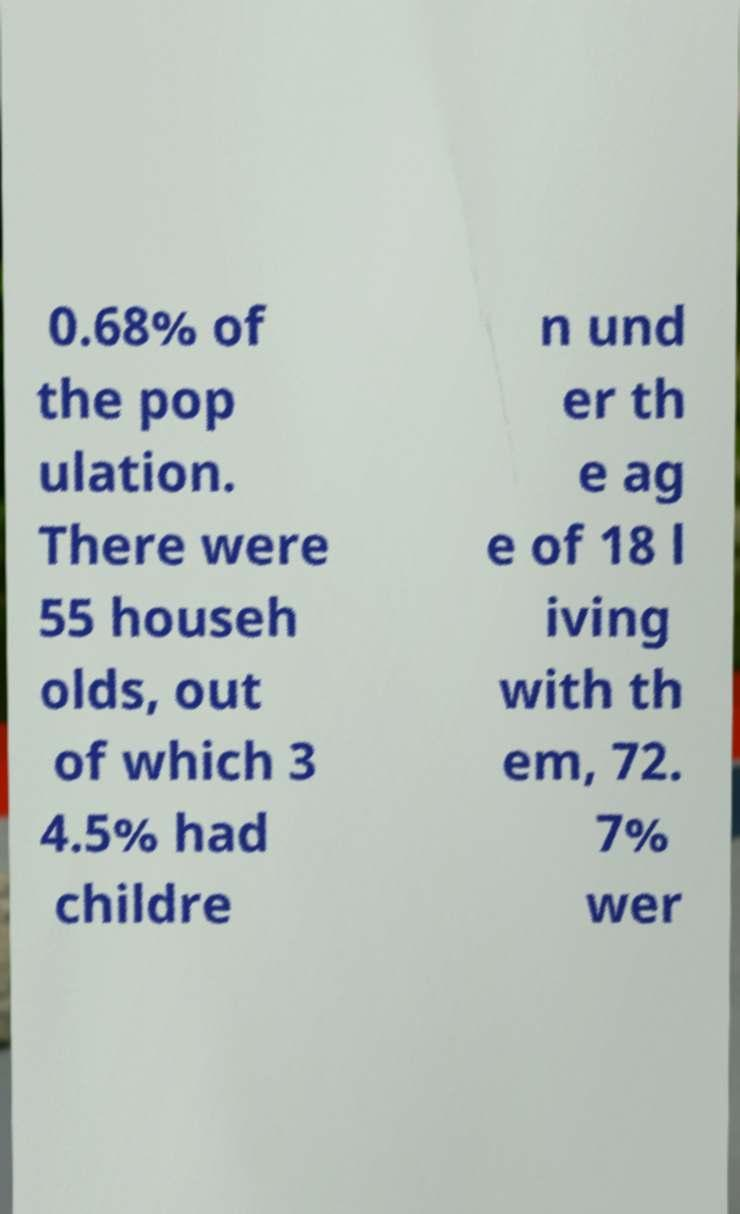Can you read and provide the text displayed in the image?This photo seems to have some interesting text. Can you extract and type it out for me? 0.68% of the pop ulation. There were 55 househ olds, out of which 3 4.5% had childre n und er th e ag e of 18 l iving with th em, 72. 7% wer 